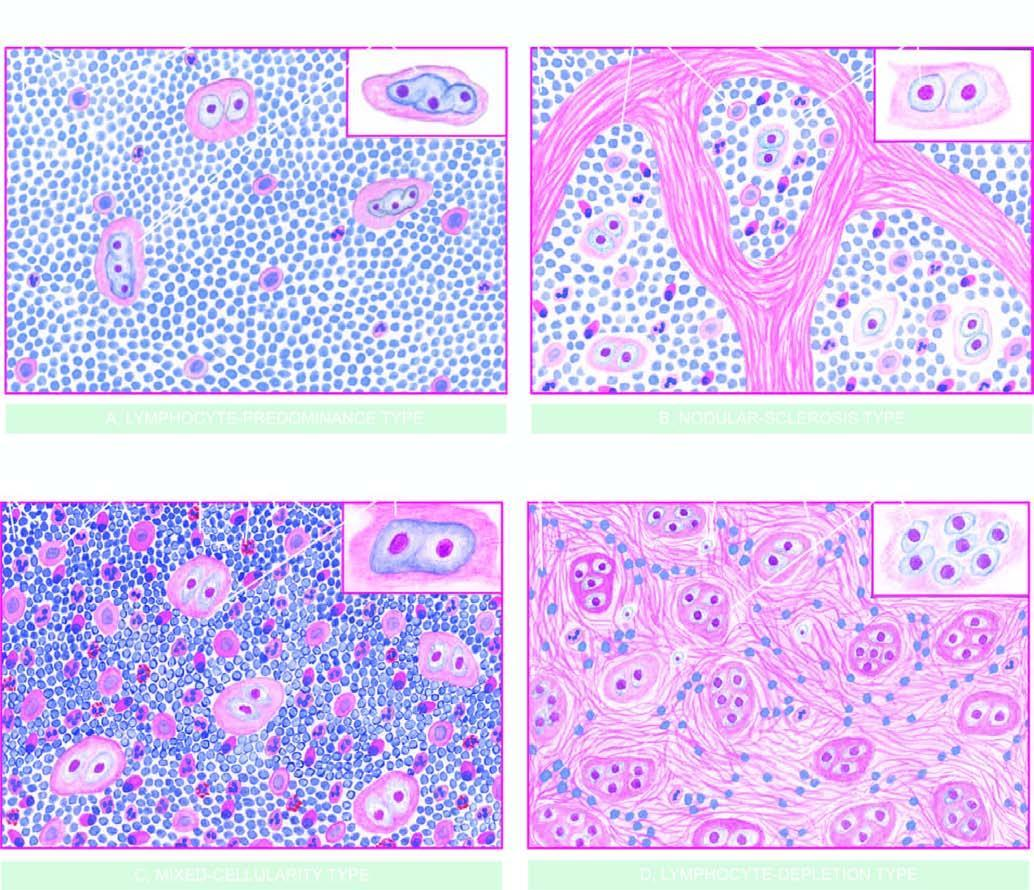does the inset on right side of each type show the morphologic variant of rs cell seen more often in particular histologic type?
Answer the question using a single word or phrase. Yes 